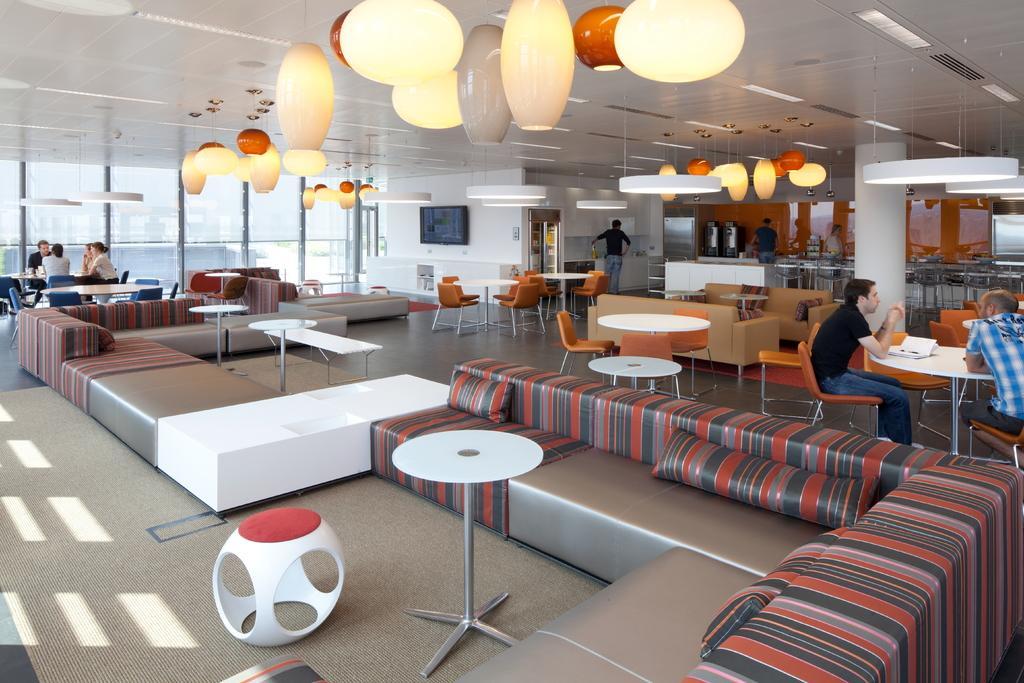Please provide a concise description of this image. In the image we can see there are many people around they are wearing clothes, they are sitting and some of them are standing. There are even sofas, chairs and tables. Here we can see the carpet and this is a floor. There are even glass windows and these are decorative lights. We can even see a pillar and a television. 